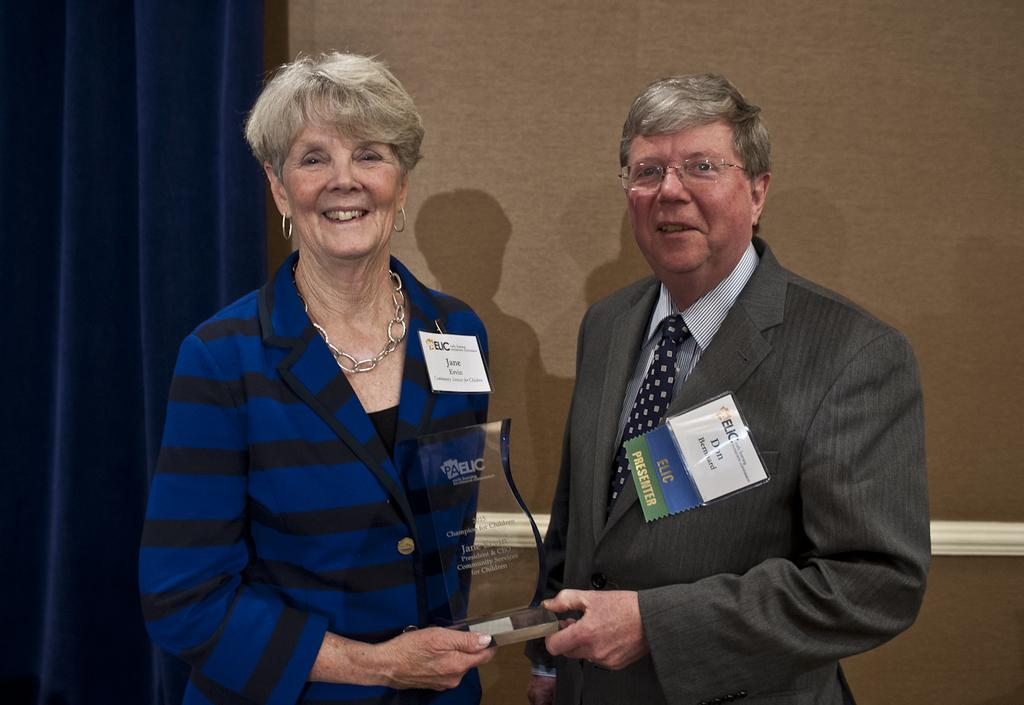How many people are in the image? There are two people in the image, a man and a woman. What are the man and woman holding in the image? The man and woman are holding a glass trophy. What expressions do the man and woman have in the image? The man and woman are smiling in the image. What can be seen on their clothing in the image? They have ID cards on them. What is visible in the background of the image? There is a wall and a curtain in the background of the image. What type of banana is the man eating in the image? There is no banana present in the image; the man and woman are holding a glass trophy. How many sons does the woman have in the image? There is no mention of sons or children in the image; it only shows a man and a woman holding a trophy. 